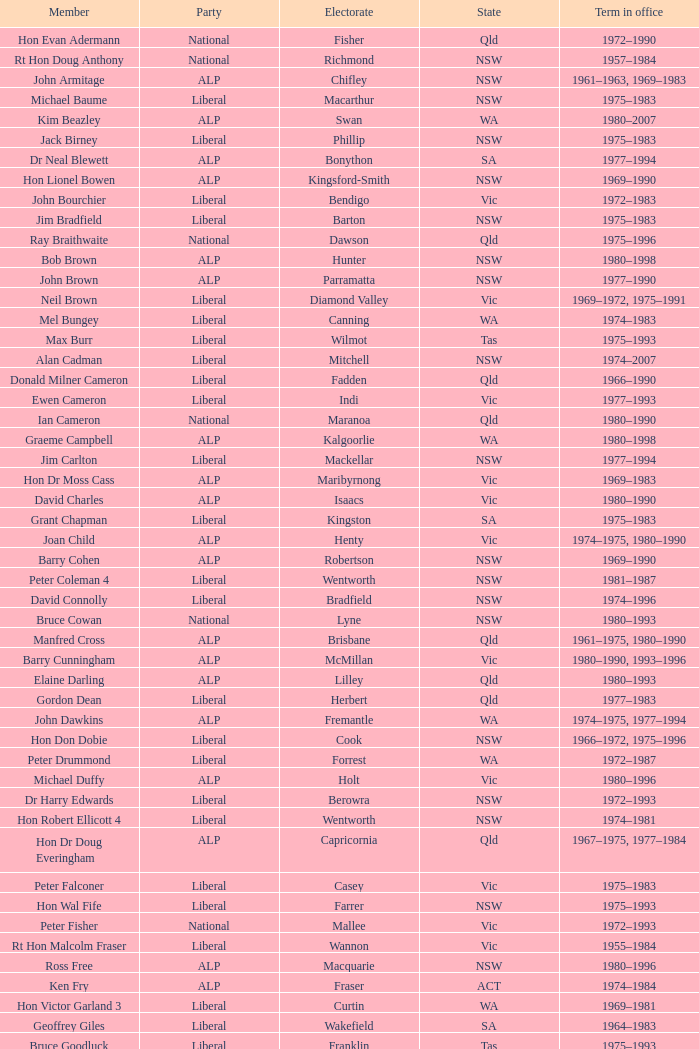In which party can mick young be found as a member? ALP. Could you parse the entire table as a dict? {'header': ['Member', 'Party', 'Electorate', 'State', 'Term in office'], 'rows': [['Hon Evan Adermann', 'National', 'Fisher', 'Qld', '1972–1990'], ['Rt Hon Doug Anthony', 'National', 'Richmond', 'NSW', '1957–1984'], ['John Armitage', 'ALP', 'Chifley', 'NSW', '1961–1963, 1969–1983'], ['Michael Baume', 'Liberal', 'Macarthur', 'NSW', '1975–1983'], ['Kim Beazley', 'ALP', 'Swan', 'WA', '1980–2007'], ['Jack Birney', 'Liberal', 'Phillip', 'NSW', '1975–1983'], ['Dr Neal Blewett', 'ALP', 'Bonython', 'SA', '1977–1994'], ['Hon Lionel Bowen', 'ALP', 'Kingsford-Smith', 'NSW', '1969–1990'], ['John Bourchier', 'Liberal', 'Bendigo', 'Vic', '1972–1983'], ['Jim Bradfield', 'Liberal', 'Barton', 'NSW', '1975–1983'], ['Ray Braithwaite', 'National', 'Dawson', 'Qld', '1975–1996'], ['Bob Brown', 'ALP', 'Hunter', 'NSW', '1980–1998'], ['John Brown', 'ALP', 'Parramatta', 'NSW', '1977–1990'], ['Neil Brown', 'Liberal', 'Diamond Valley', 'Vic', '1969–1972, 1975–1991'], ['Mel Bungey', 'Liberal', 'Canning', 'WA', '1974–1983'], ['Max Burr', 'Liberal', 'Wilmot', 'Tas', '1975–1993'], ['Alan Cadman', 'Liberal', 'Mitchell', 'NSW', '1974–2007'], ['Donald Milner Cameron', 'Liberal', 'Fadden', 'Qld', '1966–1990'], ['Ewen Cameron', 'Liberal', 'Indi', 'Vic', '1977–1993'], ['Ian Cameron', 'National', 'Maranoa', 'Qld', '1980–1990'], ['Graeme Campbell', 'ALP', 'Kalgoorlie', 'WA', '1980–1998'], ['Jim Carlton', 'Liberal', 'Mackellar', 'NSW', '1977–1994'], ['Hon Dr Moss Cass', 'ALP', 'Maribyrnong', 'Vic', '1969–1983'], ['David Charles', 'ALP', 'Isaacs', 'Vic', '1980–1990'], ['Grant Chapman', 'Liberal', 'Kingston', 'SA', '1975–1983'], ['Joan Child', 'ALP', 'Henty', 'Vic', '1974–1975, 1980–1990'], ['Barry Cohen', 'ALP', 'Robertson', 'NSW', '1969–1990'], ['Peter Coleman 4', 'Liberal', 'Wentworth', 'NSW', '1981–1987'], ['David Connolly', 'Liberal', 'Bradfield', 'NSW', '1974–1996'], ['Bruce Cowan', 'National', 'Lyne', 'NSW', '1980–1993'], ['Manfred Cross', 'ALP', 'Brisbane', 'Qld', '1961–1975, 1980–1990'], ['Barry Cunningham', 'ALP', 'McMillan', 'Vic', '1980–1990, 1993–1996'], ['Elaine Darling', 'ALP', 'Lilley', 'Qld', '1980–1993'], ['Gordon Dean', 'Liberal', 'Herbert', 'Qld', '1977–1983'], ['John Dawkins', 'ALP', 'Fremantle', 'WA', '1974–1975, 1977–1994'], ['Hon Don Dobie', 'Liberal', 'Cook', 'NSW', '1966–1972, 1975–1996'], ['Peter Drummond', 'Liberal', 'Forrest', 'WA', '1972–1987'], ['Michael Duffy', 'ALP', 'Holt', 'Vic', '1980–1996'], ['Dr Harry Edwards', 'Liberal', 'Berowra', 'NSW', '1972–1993'], ['Hon Robert Ellicott 4', 'Liberal', 'Wentworth', 'NSW', '1974–1981'], ['Hon Dr Doug Everingham', 'ALP', 'Capricornia', 'Qld', '1967–1975, 1977–1984'], ['Peter Falconer', 'Liberal', 'Casey', 'Vic', '1975–1983'], ['Hon Wal Fife', 'Liberal', 'Farrer', 'NSW', '1975–1993'], ['Peter Fisher', 'National', 'Mallee', 'Vic', '1972–1993'], ['Rt Hon Malcolm Fraser', 'Liberal', 'Wannon', 'Vic', '1955–1984'], ['Ross Free', 'ALP', 'Macquarie', 'NSW', '1980–1996'], ['Ken Fry', 'ALP', 'Fraser', 'ACT', '1974–1984'], ['Hon Victor Garland 3', 'Liberal', 'Curtin', 'WA', '1969–1981'], ['Geoffrey Giles', 'Liberal', 'Wakefield', 'SA', '1964–1983'], ['Bruce Goodluck', 'Liberal', 'Franklin', 'Tas', '1975–1993'], ['Hon Ray Groom', 'Liberal', 'Braddon', 'Tas', '1975–1984'], ['Steele Hall 2', 'Liberal', 'Boothby', 'SA', '1981–1996'], ['Graham Harris', 'Liberal', 'Chisholm', 'Vic', '1980–1983'], ['Bob Hawke', 'ALP', 'Wills', 'Vic', '1980–1992'], ['Hon Bill Hayden', 'ALP', 'Oxley', 'Qld', '1961–1988'], ['Noel Hicks', 'National', 'Riverina', 'NSW', '1980–1998'], ['John Hodges', 'Liberal', 'Petrie', 'Qld', '1974–1983, 1984–1987'], ['Michael Hodgman', 'Liberal', 'Denison', 'Tas', '1975–1987'], ['Clyde Holding', 'ALP', 'Melbourne Ports', 'Vic', '1977–1998'], ['Hon John Howard', 'Liberal', 'Bennelong', 'NSW', '1974–2007'], ['Brian Howe', 'ALP', 'Batman', 'Vic', '1977–1996'], ['Ben Humphreys', 'ALP', 'Griffith', 'Qld', '1977–1996'], ['Hon Ralph Hunt', 'National', 'Gwydir', 'NSW', '1969–1989'], ['Chris Hurford', 'ALP', 'Adelaide', 'SA', '1969–1988'], ['John Hyde', 'Liberal', 'Moore', 'WA', '1974–1983'], ['Ted Innes', 'ALP', 'Melbourne', 'Vic', '1972–1983'], ['Ralph Jacobi', 'ALP', 'Hawker', 'SA', '1969–1987'], ['Alan Jarman', 'Liberal', 'Deakin', 'Vic', '1966–1983'], ['Dr Harry Jenkins', 'ALP', 'Scullin', 'Vic', '1969–1985'], ['Hon Les Johnson', 'ALP', 'Hughes', 'NSW', '1955–1966, 1969–1984'], ['Barry Jones', 'ALP', 'Lalor', 'Vic', '1977–1998'], ['Hon Charles Jones', 'ALP', 'Newcastle', 'NSW', '1958–1983'], ['David Jull', 'Liberal', 'Bowman', 'Qld', '1975–1983, 1984–2007'], ['Hon Bob Katter', 'National', 'Kennedy', 'Qld', '1966–1990'], ['Hon Paul Keating', 'ALP', 'Blaxland', 'NSW', '1969–1996'], ['Ros Kelly', 'ALP', 'Canberra', 'ACT', '1980–1995'], ['Lewis Kent', 'ALP', 'Hotham', 'Vic', '1980–1990'], ['John Kerin', 'ALP', 'Werriwa', 'NSW', '1972–1975, 1978–1994'], ['Hon Jim Killen', 'Liberal', 'Moreton', 'Qld', '1955–1983'], ['Dr Dick Klugman', 'ALP', 'Prospect', 'NSW', '1969–1990'], ['Bruce Lloyd', 'National', 'Murray', 'Vic', '1971–1996'], ['Stephen Lusher', 'National', 'Hume', 'NSW', '1974–1984'], ['Rt Hon Phillip Lynch 6', 'Liberal', 'Flinders', 'Vic', '1966–1982'], ['Hon Michael MacKellar', 'Liberal', 'Warringah', 'NSW', '1969–1994'], ['Sandy Mackenzie', 'National', 'Calare', 'NSW', '1975–1983'], ['Hon Ian Macphee', 'Liberal', 'Balaclava', 'Vic', '1974–1990'], ['Michael Maher 5', 'ALP', 'Lowe', 'NSW', '1982–1987'], ['Ross McLean', 'Liberal', 'Perth', 'WA', '1975–1983'], ['Hon John McLeay 2', 'Liberal', 'Boothby', 'SA', '1966–1981'], ['Leo McLeay', 'ALP', 'Grayndler', 'NSW', '1979–2004'], ['Leslie McMahon', 'ALP', 'Sydney', 'NSW', '1975–1983'], ['Rt Hon Sir William McMahon 5', 'Liberal', 'Lowe', 'NSW', '1949–1981'], ['Tom McVeigh', 'National', 'Darling Downs', 'Qld', '1972–1988'], ['John Mildren', 'ALP', 'Ballarat', 'Vic', '1980–1990'], ['Clarrie Millar', 'National', 'Wide Bay', 'Qld', '1974–1990'], ['Peter Milton', 'ALP', 'La Trobe', 'Vic', '1980–1990'], ['John Moore', 'Liberal', 'Ryan', 'Qld', '1975–2001'], ['Peter Morris', 'ALP', 'Shortland', 'NSW', '1972–1998'], ['Hon Bill Morrison', 'ALP', 'St George', 'NSW', '1969–1975, 1980–1984'], ['John Mountford', 'ALP', 'Banks', 'NSW', '1980–1990'], ['Hon Kevin Newman', 'Liberal', 'Bass', 'Tas', '1975–1984'], ['Hon Peter Nixon', 'National', 'Gippsland', 'Vic', '1961–1983'], ["Frank O'Keefe", 'National', 'Paterson', 'NSW', '1969–1984'], ['Hon Andrew Peacock', 'Liberal', 'Kooyong', 'Vic', '1966–1994'], ['James Porter', 'Liberal', 'Barker', 'SA', '1975–1990'], ['Peter Reith 6', 'Liberal', 'Flinders', 'Vic', '1982–1983, 1984–2001'], ['Hon Eric Robinson 1', 'Liberal', 'McPherson', 'Qld', '1972–1990'], ['Hon Ian Robinson', 'National', 'Cowper', 'NSW', '1963–1981'], ['Allan Rocher 3', 'Liberal', 'Curtin', 'WA', '1981–1998'], ['Philip Ruddock', 'Liberal', 'Dundas', 'NSW', '1973–present'], ['Murray Sainsbury', 'Liberal', 'Eden-Monaro', 'NSW', '1975–1983'], ['Hon Gordon Scholes', 'ALP', 'Corio', 'Vic', '1967–1993'], ['John Scott', 'ALP', 'Hindmarsh', 'SA', '1980–1993'], ['Peter Shack', 'Liberal', 'Tangney', 'WA', '1977–1983, 1984–1993'], ['Roger Shipton', 'Liberal', 'Higgins', 'Vic', '1975–1990'], ['Rt Hon Ian Sinclair', 'National', 'New England', 'NSW', '1963–1998'], ['Rt Hon Sir Billy Snedden', 'Liberal', 'Bruce', 'Vic', '1955–1983'], ['John Spender', 'Liberal', 'North Sydney', 'NSW', '1980–1990'], ['Hon Tony Street', 'Liberal', 'Corangamite', 'Vic', '1966–1984'], ['Grant Tambling', 'CLP', 'Northern Territory', 'NT', '1980–1983'], ['Dr Andrew Theophanous', 'ALP', 'Burke', 'Vic', '1980–2001'], ['Hon David Thomson', 'National', 'Leichhardt', 'Qld', '1975–1983'], ['Wilson Tuckey', 'Liberal', "O'Connor", 'WA', '1980–2010'], ['Hon Tom Uren', 'ALP', 'Reid', 'NSW', '1958–1990'], ['Hon Ian Viner', 'Liberal', 'Stirling', 'WA', '1972–1983'], ['Laurie Wallis', 'ALP', 'Grey', 'SA', '1969–1983'], ['Stewart West', 'ALP', 'Cunningham', 'NSW', '1977–1993'], ['Peter White 1', 'Liberal', 'McPherson', 'Qld', '1981–1990'], ['Ralph Willis', 'ALP', 'Gellibrand', 'Vic', '1972–1998'], ['Ian Wilson', 'Liberal', 'Sturt', 'SA', '1966–1969, 1972–1993'], ['Mick Young', 'ALP', 'Port Adelaide', 'SA', '1974–1988']]} 